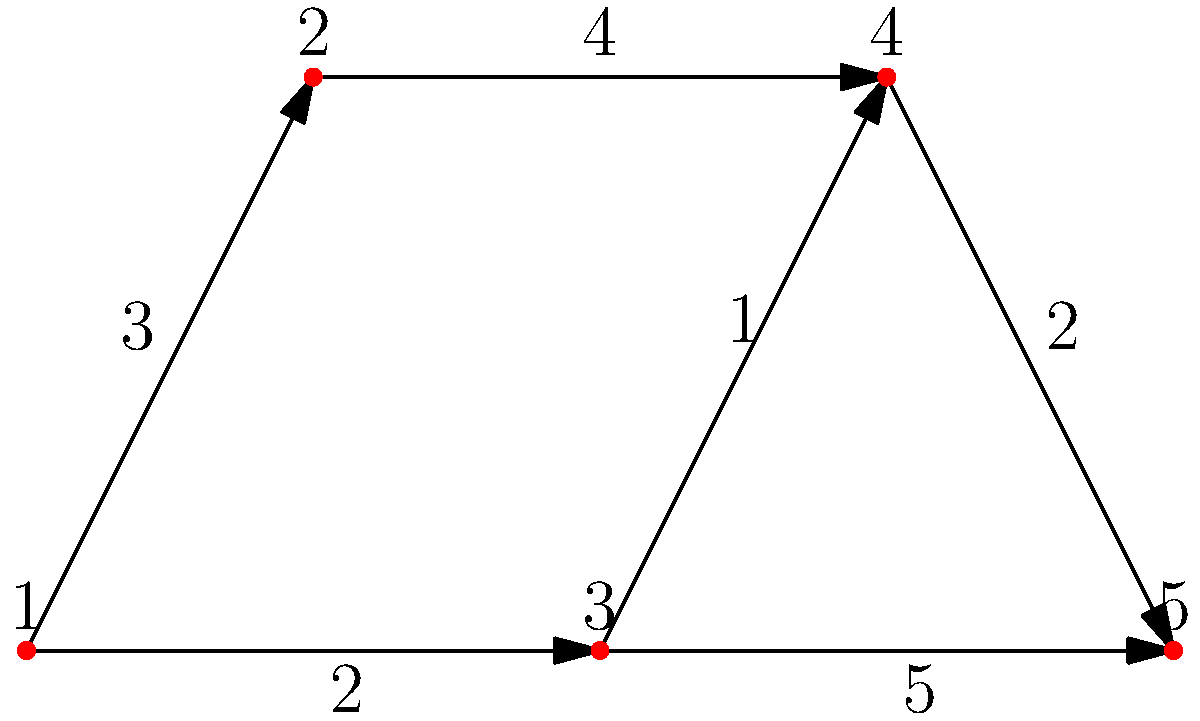In this forest maze, each node represents a clearing, and each edge represents a path between clearings. The numbers on the edges indicate the time (in minutes) it takes to travel that path. If you start at clearing 1 and want to reach clearing 5 as quickly as possible, what is the shortest path and how long does it take? Let's approach this step-by-step using Dijkstra's algorithm:

1) Start at node 1 with a distance of 0. Set all other nodes to infinity.
   Current distances: [0, ∞, ∞, ∞, ∞]

2) Explore neighbors of node 1:
   - To node 2: 0 + 3 = 3
   - To node 3: 0 + 2 = 2
   Updated distances: [0, 3, 2, ∞, ∞]

3) Move to node 3 (smallest unexplored distance).
   Explore neighbors of node 3:
   - To node 4: 2 + 1 = 3
   - To node 5: 2 + 5 = 7
   Updated distances: [0, 3, 2, 3, 7]

4) Move to node 2 or 4 (both have distance 3). Let's choose node 2.
   Explore neighbor of node 2:
   - To node 4: 3 + 4 = 7 (not better than current 3)
   Distances unchanged: [0, 3, 2, 3, 7]

5) Move to node 4.
   Explore neighbor of node 4:
   - To node 5: 3 + 2 = 5
   Updated distances: [0, 3, 2, 3, 5]

6) Move to node 5. All nodes explored.

The shortest path is 1 -> 3 -> 4 -> 5, with a total time of 5 minutes.
Answer: 1 -> 3 -> 4 -> 5, 5 minutes 